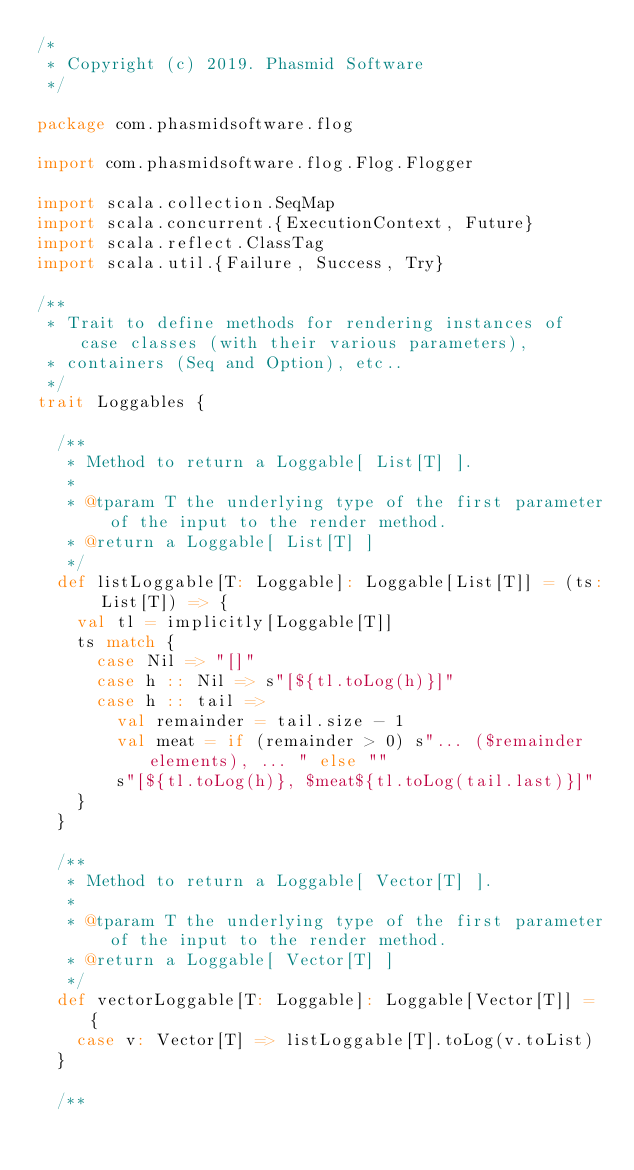Convert code to text. <code><loc_0><loc_0><loc_500><loc_500><_Scala_>/*
 * Copyright (c) 2019. Phasmid Software
 */

package com.phasmidsoftware.flog

import com.phasmidsoftware.flog.Flog.Flogger

import scala.collection.SeqMap
import scala.concurrent.{ExecutionContext, Future}
import scala.reflect.ClassTag
import scala.util.{Failure, Success, Try}

/**
 * Trait to define methods for rendering instances of case classes (with their various parameters),
 * containers (Seq and Option), etc..
 */
trait Loggables {

  /**
   * Method to return a Loggable[ List[T] ].
   *
   * @tparam T the underlying type of the first parameter of the input to the render method.
   * @return a Loggable[ List[T] ]
   */
  def listLoggable[T: Loggable]: Loggable[List[T]] = (ts: List[T]) => {
    val tl = implicitly[Loggable[T]]
    ts match {
      case Nil => "[]"
      case h :: Nil => s"[${tl.toLog(h)}]"
      case h :: tail =>
        val remainder = tail.size - 1
        val meat = if (remainder > 0) s"... ($remainder elements), ... " else ""
        s"[${tl.toLog(h)}, $meat${tl.toLog(tail.last)}]"
    }
  }

  /**
   * Method to return a Loggable[ Vector[T] ].
   *
   * @tparam T the underlying type of the first parameter of the input to the render method.
   * @return a Loggable[ Vector[T] ]
   */
  def vectorLoggable[T: Loggable]: Loggable[Vector[T]] = {
    case v: Vector[T] => listLoggable[T].toLog(v.toList)
  }

  /**</code> 